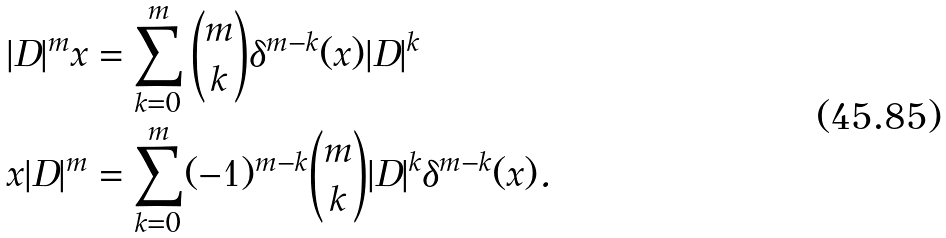<formula> <loc_0><loc_0><loc_500><loc_500>| D | ^ { m } x & = \sum _ { k = 0 } ^ { m } \binom { m } { k } \delta ^ { m - k } ( x ) | D | ^ { k } \\ x | D | ^ { m } & = \sum _ { k = 0 } ^ { m } ( - 1 ) ^ { m - k } \binom { m } { k } | D | ^ { k } \delta ^ { m - k } ( x ) .</formula> 